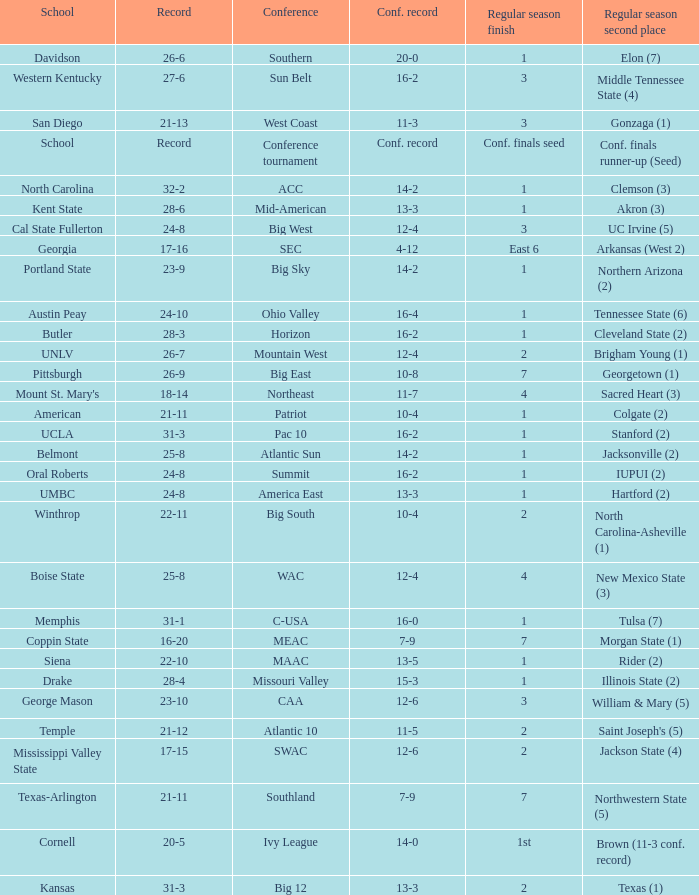What was the overall record of UMBC? 24-8. 